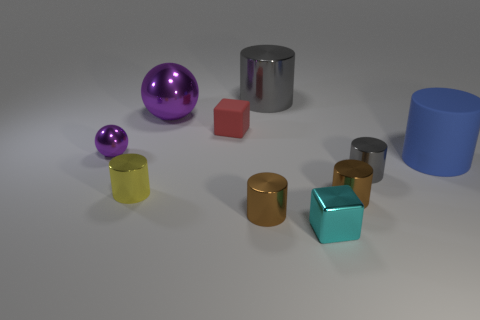Subtract all gray cylinders. How many cylinders are left? 4 Subtract all blue cylinders. How many cylinders are left? 5 Subtract 1 cylinders. How many cylinders are left? 5 Subtract all cyan cylinders. Subtract all yellow balls. How many cylinders are left? 6 Subtract all cubes. How many objects are left? 8 Subtract 0 red spheres. How many objects are left? 10 Subtract all big blue rubber cylinders. Subtract all yellow shiny cylinders. How many objects are left? 8 Add 1 small cyan metallic things. How many small cyan metallic things are left? 2 Add 10 large yellow shiny objects. How many large yellow shiny objects exist? 10 